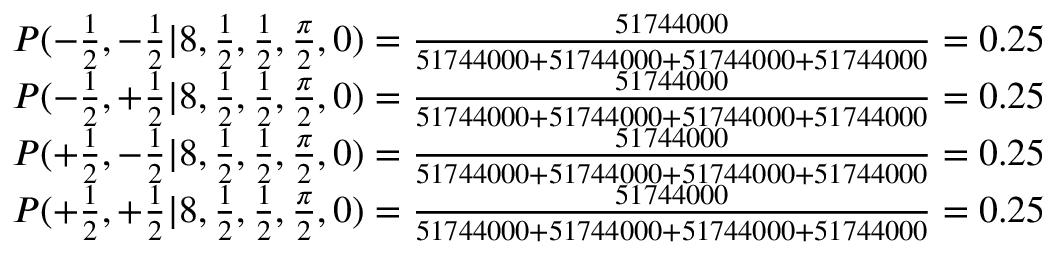Convert formula to latex. <formula><loc_0><loc_0><loc_500><loc_500>\begin{array} { c c } { P ( - \frac { 1 } { 2 } , - \frac { 1 } { 2 } | 8 , \frac { 1 } { 2 } , \frac { 1 } { 2 } , \frac { \pi } { 2 } , 0 ) = \frac { 5 1 7 4 4 0 0 0 } { 5 1 7 4 4 0 0 0 + 5 1 7 4 4 0 0 0 + 5 1 7 4 4 0 0 0 + 5 1 7 4 4 0 0 0 } = 0 . 2 5 } \\ { P ( - \frac { 1 } { 2 } , + \frac { 1 } { 2 } | 8 , \frac { 1 } { 2 } , \frac { 1 } { 2 } , \frac { \pi } { 2 } , 0 ) = \frac { 5 1 7 4 4 0 0 0 } { 5 1 7 4 4 0 0 0 + 5 1 7 4 4 0 0 0 + 5 1 7 4 4 0 0 0 + 5 1 7 4 4 0 0 0 } = 0 . 2 5 } \\ { P ( + \frac { 1 } { 2 } , - \frac { 1 } { 2 } | 8 , \frac { 1 } { 2 } , \frac { 1 } { 2 } , \frac { \pi } { 2 } , 0 ) = \frac { 5 1 7 4 4 0 0 0 } { 5 1 7 4 4 0 0 0 + 5 1 7 4 4 0 0 0 + 5 1 7 4 4 0 0 0 + 5 1 7 4 4 0 0 0 } = 0 . 2 5 } \\ { P ( + \frac { 1 } { 2 } , + \frac { 1 } { 2 } | 8 , \frac { 1 } { 2 } , \frac { 1 } { 2 } , \frac { \pi } { 2 } , 0 ) = \frac { 5 1 7 4 4 0 0 0 } { 5 1 7 4 4 0 0 0 + 5 1 7 4 4 0 0 0 + 5 1 7 4 4 0 0 0 + 5 1 7 4 4 0 0 0 } = 0 . 2 5 } \end{array}</formula> 